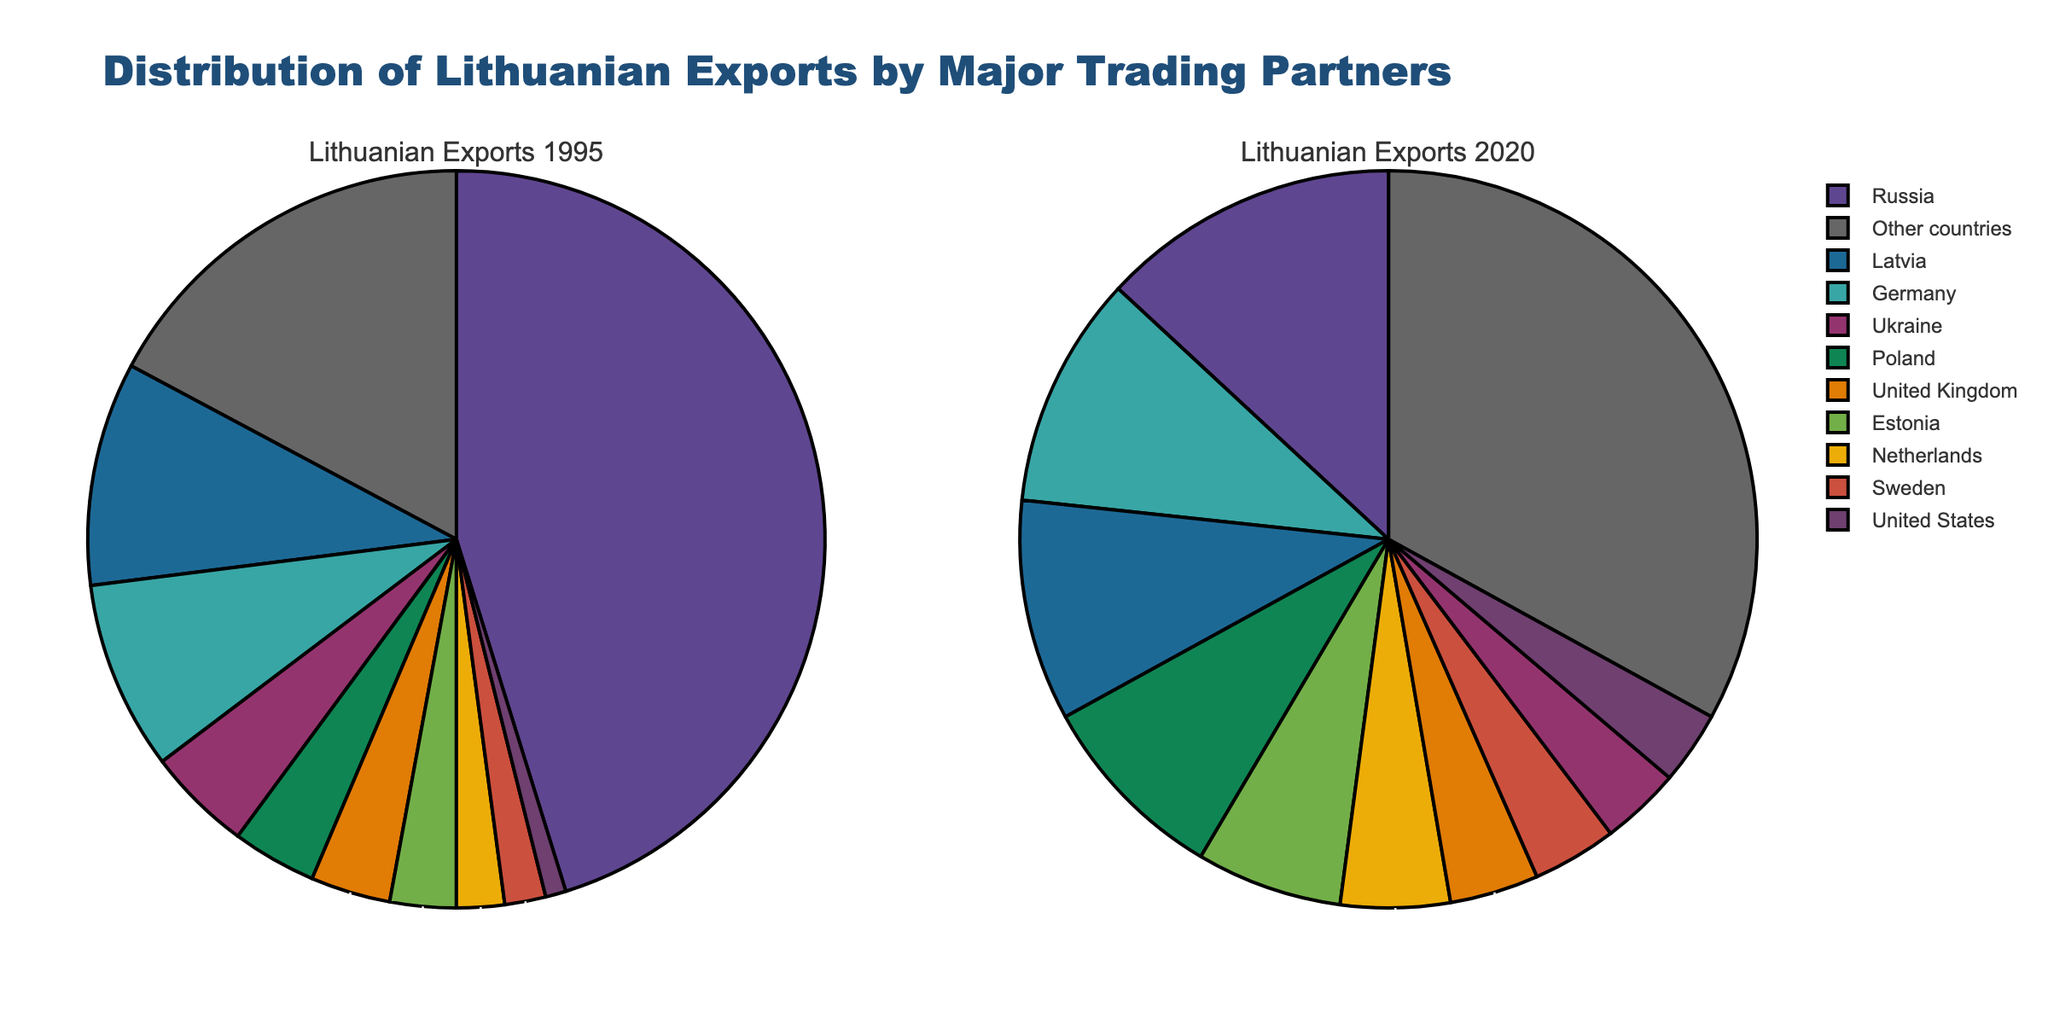What is the title of the figure? The title is prominently displayed at the top of the figure. It reads "Distribution of Lithuanian Exports by Major Trading Partners."
Answer: Distribution of Lithuanian Exports by Major Trading Partners Which country was Lithuania's largest export partner in 1995? The largest export partner in the 1995 pie chart is the segment with the largest percentage, which is Russia.
Answer: Russia How did the export share to Germany change from 1995 to 2020? The export share to Germany increased. In 1995, it was 8.3%, and in 2020, it rose to 10.2%.
Answer: Increased Which country showed the most significant drop in export share from 1995 to 2020? The largest drop in export share is seen in Russia, falling from 45.2% in 1995 to 13.1% in 2020.
Answer: Russia What is the combined export share of Latvia and Poland in 2020? To find the combined share, add the percentages for Latvia and Poland in 2020: 9.7% + 8.5% = 18.2%.
Answer: 18.2% Which countries have an export share of less than 4% in 2020? The pie chart for 2020 shows that Ukraine and the United States have export shares below 4% (3.5% and 3.2%, respectively).
Answer: Ukraine and the United States What is the difference in export share to the United Kingdom between 1995 and 2020? The export share to the United Kingdom was 3.5% in 1995 and 3.9% in 2020. The difference is 3.9% - 3.5% = 0.4%.
Answer: 0.4% How has the export share to the category "Other countries" changed from 1995 to 2020? In 1995, the "Other countries" category had an export share of 17.2%. By 2020, this share increased to 33.0%. This is a significant increase.
Answer: Increased Which country had an export share close to 10% in both 1995 and 2020? Latvia's export share was 9.8% in 1995 and slightly decreased to 9.7% in 2020, remaining close to 10% both years.
Answer: Latvia What is the combined share of Lithuania's exports to Estonia and the Netherlands in 2020? Adding the shares for Estonia (6.4%) and the Netherlands (4.8%) in 2020, the total is 6.4% + 4.8% = 11.2%.
Answer: 11.2% 